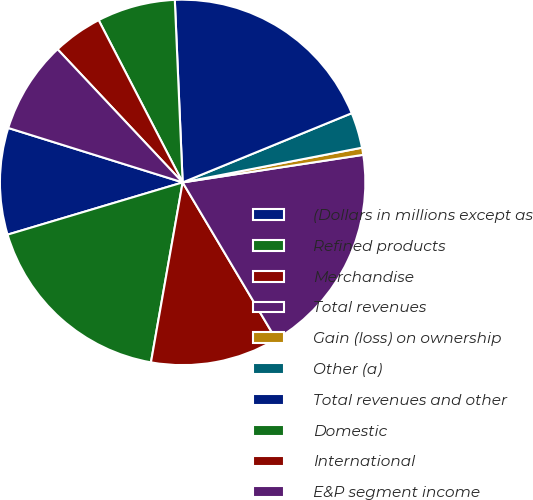<chart> <loc_0><loc_0><loc_500><loc_500><pie_chart><fcel>(Dollars in millions except as<fcel>Refined products<fcel>Merchandise<fcel>Total revenues<fcel>Gain (loss) on ownership<fcel>Other (a)<fcel>Total revenues and other<fcel>Domestic<fcel>International<fcel>E&P segment income<nl><fcel>9.43%<fcel>17.61%<fcel>11.32%<fcel>18.87%<fcel>0.63%<fcel>3.14%<fcel>19.5%<fcel>6.92%<fcel>4.4%<fcel>8.18%<nl></chart> 